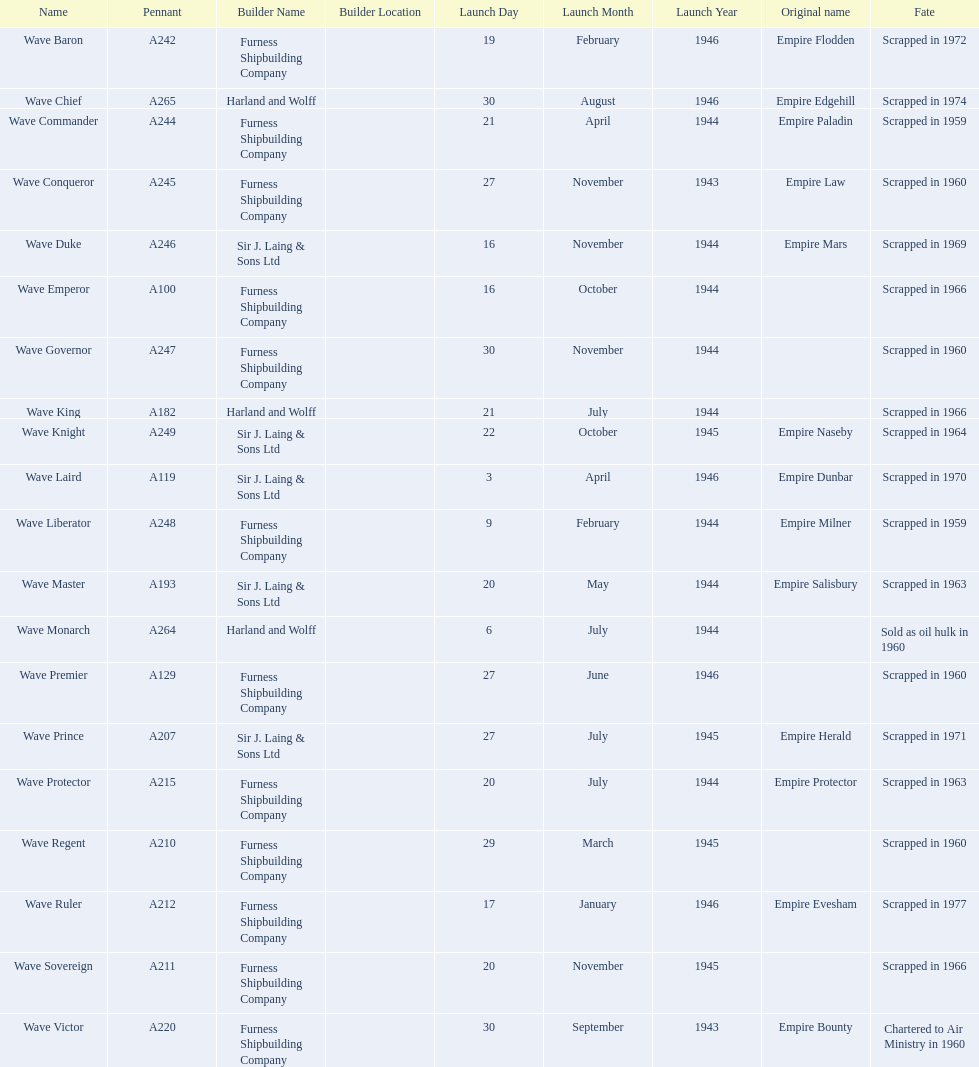Would you mind parsing the complete table? {'header': ['Name', 'Pennant', 'Builder Name', 'Builder Location', 'Launch Day', 'Launch Month', 'Launch Year', 'Original name', 'Fate'], 'rows': [['Wave Baron', 'A242', 'Furness Shipbuilding Company', '', '19', 'February', '1946', 'Empire Flodden', 'Scrapped in 1972'], ['Wave Chief', 'A265', 'Harland and Wolff', '', '30', 'August', '1946', 'Empire Edgehill', 'Scrapped in 1974'], ['Wave Commander', 'A244', 'Furness Shipbuilding Company', '', '21', 'April', '1944', 'Empire Paladin', 'Scrapped in 1959'], ['Wave Conqueror', 'A245', 'Furness Shipbuilding Company', '', '27', 'November', '1943', 'Empire Law', 'Scrapped in 1960'], ['Wave Duke', 'A246', 'Sir J. Laing & Sons Ltd', '', '16', 'November', '1944', 'Empire Mars', 'Scrapped in 1969'], ['Wave Emperor', 'A100', 'Furness Shipbuilding Company', '', '16', 'October', '1944', '', 'Scrapped in 1966'], ['Wave Governor', 'A247', 'Furness Shipbuilding Company', '', '30', 'November', '1944', '', 'Scrapped in 1960'], ['Wave King', 'A182', 'Harland and Wolff', '', '21', 'July', '1944', '', 'Scrapped in 1966'], ['Wave Knight', 'A249', 'Sir J. Laing & Sons Ltd', '', '22', 'October', '1945', 'Empire Naseby', 'Scrapped in 1964'], ['Wave Laird', 'A119', 'Sir J. Laing & Sons Ltd', '', '3', 'April', '1946', 'Empire Dunbar', 'Scrapped in 1970'], ['Wave Liberator', 'A248', 'Furness Shipbuilding Company', '', '9', 'February', '1944', 'Empire Milner', 'Scrapped in 1959'], ['Wave Master', 'A193', 'Sir J. Laing & Sons Ltd', '', '20', 'May', '1944', 'Empire Salisbury', 'Scrapped in 1963'], ['Wave Monarch', 'A264', 'Harland and Wolff', '', '6', 'July', '1944', '', 'Sold as oil hulk in 1960'], ['Wave Premier', 'A129', 'Furness Shipbuilding Company', '', '27', 'June', '1946', '', 'Scrapped in 1960'], ['Wave Prince', 'A207', 'Sir J. Laing & Sons Ltd', '', '27', 'July', '1945', 'Empire Herald', 'Scrapped in 1971'], ['Wave Protector', 'A215', 'Furness Shipbuilding Company', '', '20', 'July', '1944', 'Empire Protector', 'Scrapped in 1963'], ['Wave Regent', 'A210', 'Furness Shipbuilding Company', '', '29', 'March', '1945', '', 'Scrapped in 1960'], ['Wave Ruler', 'A212', 'Furness Shipbuilding Company', '', '17', 'January', '1946', 'Empire Evesham', 'Scrapped in 1977'], ['Wave Sovereign', 'A211', 'Furness Shipbuilding Company', '', '20', 'November', '1945', '', 'Scrapped in 1966'], ['Wave Victor', 'A220', 'Furness Shipbuilding Company', '', '30', 'September', '1943', 'Empire Bounty', 'Chartered to Air Ministry in 1960']]} Which other ship was launched in the same year as the wave victor? Wave Conqueror. 